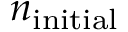Convert formula to latex. <formula><loc_0><loc_0><loc_500><loc_500>n _ { i n i t i a l }</formula> 